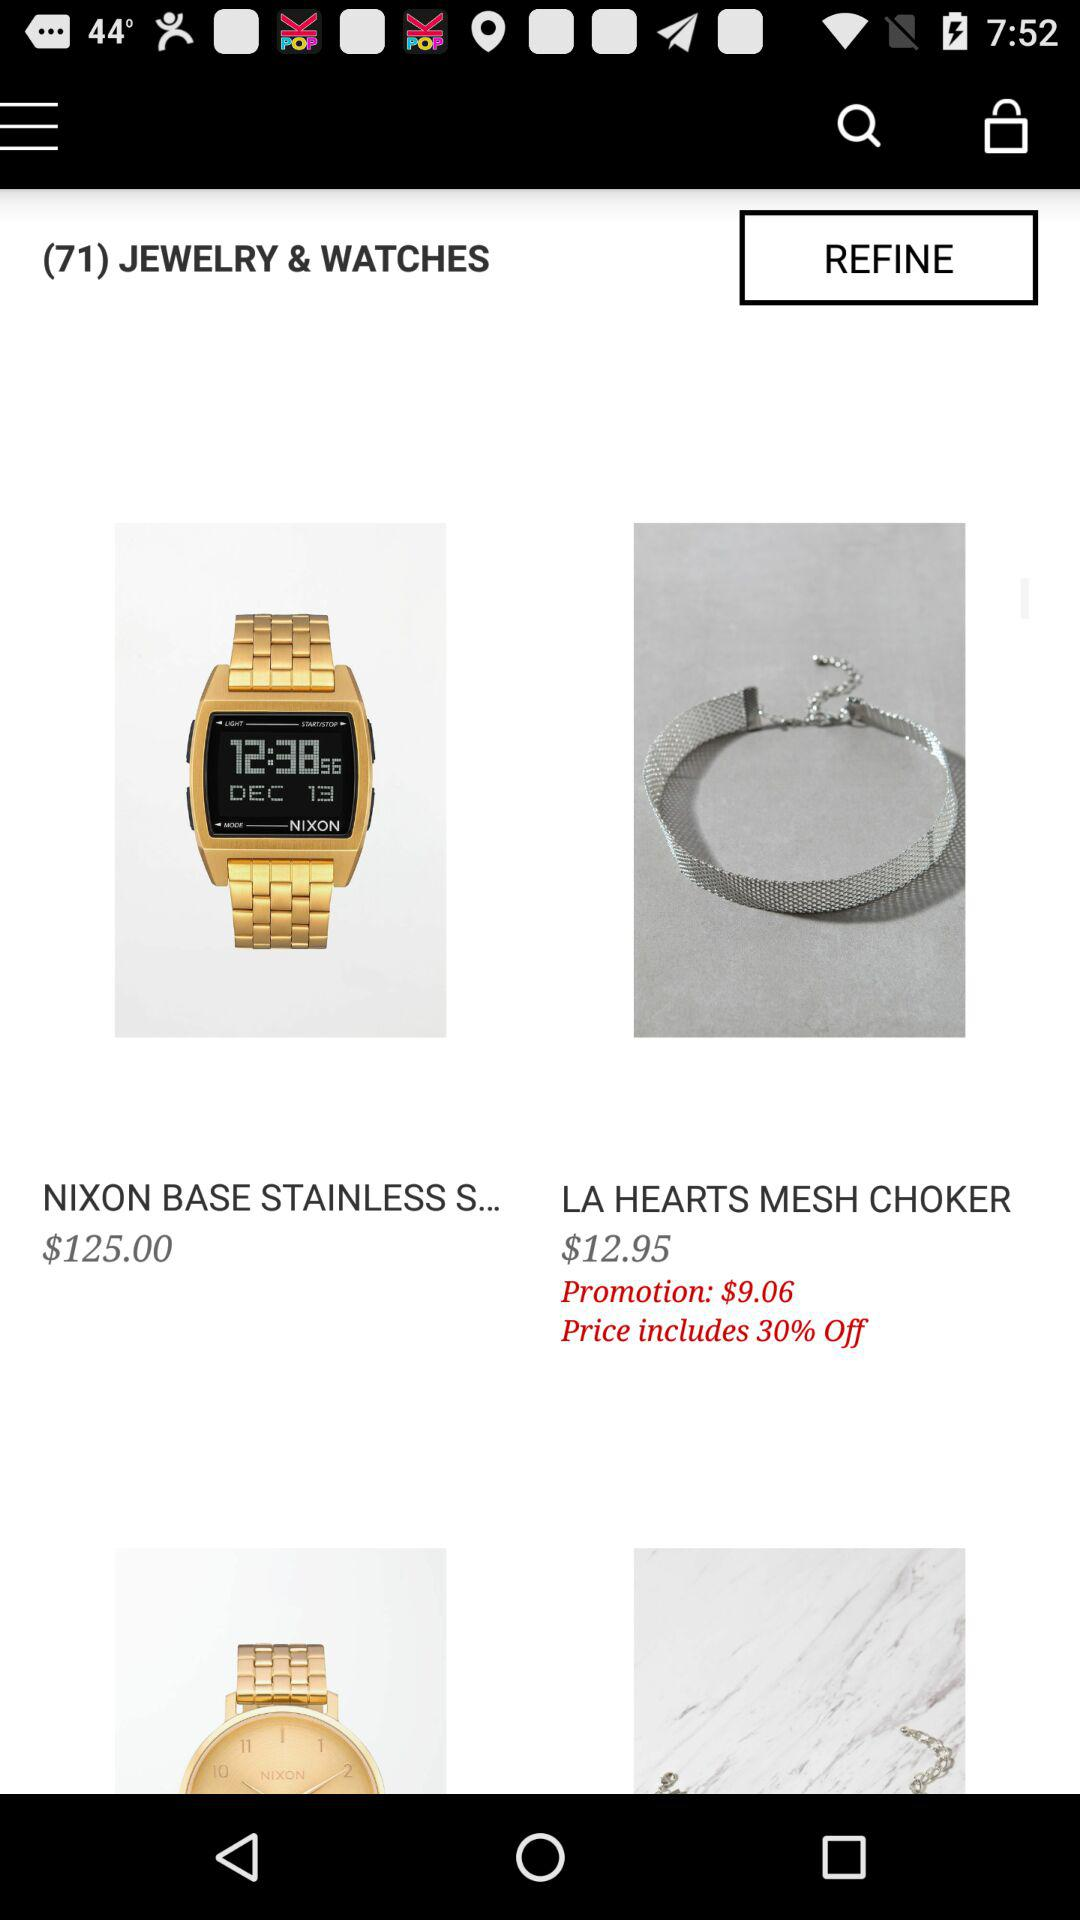How much is the price of the Nixon Base Stainless Steel watch?
Answer the question using a single word or phrase. $125.00 